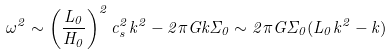Convert formula to latex. <formula><loc_0><loc_0><loc_500><loc_500>\omega ^ { 2 } \sim \left ( \frac { L _ { 0 } } { H _ { 0 } } \right ) ^ { 2 } c _ { s } ^ { 2 } k ^ { 2 } - 2 \pi G k \Sigma _ { 0 } \sim 2 \pi G \Sigma _ { 0 } ( L _ { 0 } k ^ { 2 } - k )</formula> 